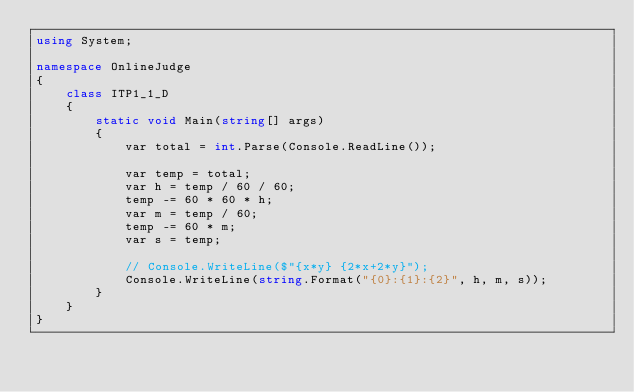Convert code to text. <code><loc_0><loc_0><loc_500><loc_500><_C#_>using System;

namespace OnlineJudge
{
    class ITP1_1_D
    {
        static void Main(string[] args)
        {
            var total = int.Parse(Console.ReadLine());

            var temp = total;
            var h = temp / 60 / 60;
            temp -= 60 * 60 * h;
            var m = temp / 60;
            temp -= 60 * m;
            var s = temp;

            // Console.WriteLine($"{x*y} {2*x+2*y}");
            Console.WriteLine(string.Format("{0}:{1}:{2}", h, m, s));
        }
    }
}</code> 